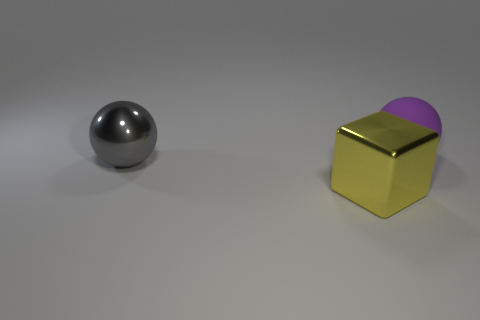Subtract all blocks. How many objects are left? 2 Add 1 big gray rubber balls. How many objects exist? 4 Subtract 1 yellow blocks. How many objects are left? 2 Subtract all cyan matte cylinders. Subtract all big yellow shiny things. How many objects are left? 2 Add 3 big yellow metallic things. How many big yellow metallic things are left? 4 Add 1 purple matte spheres. How many purple matte spheres exist? 2 